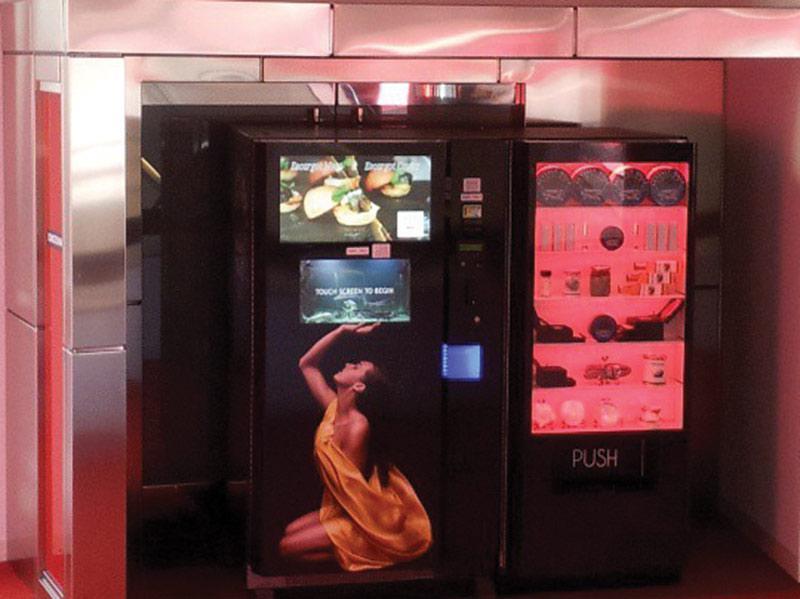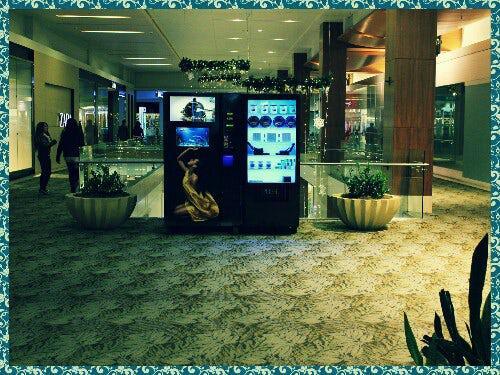The first image is the image on the left, the second image is the image on the right. For the images displayed, is the sentence "At least one image shows at least one person standing in front of a vending machine." factually correct? Answer yes or no. No. The first image is the image on the left, the second image is the image on the right. For the images shown, is this caption "A person is standing directly in front of a vending machine decorated with a woman's image, in one picture." true? Answer yes or no. No. The first image is the image on the left, the second image is the image on the right. For the images displayed, is the sentence "The right image has at least one human facing towards the right in front of a vending machine." factually correct? Answer yes or no. No. The first image is the image on the left, the second image is the image on the right. Considering the images on both sides, is "One of the images has a male looking directly at the machine." valid? Answer yes or no. No. 